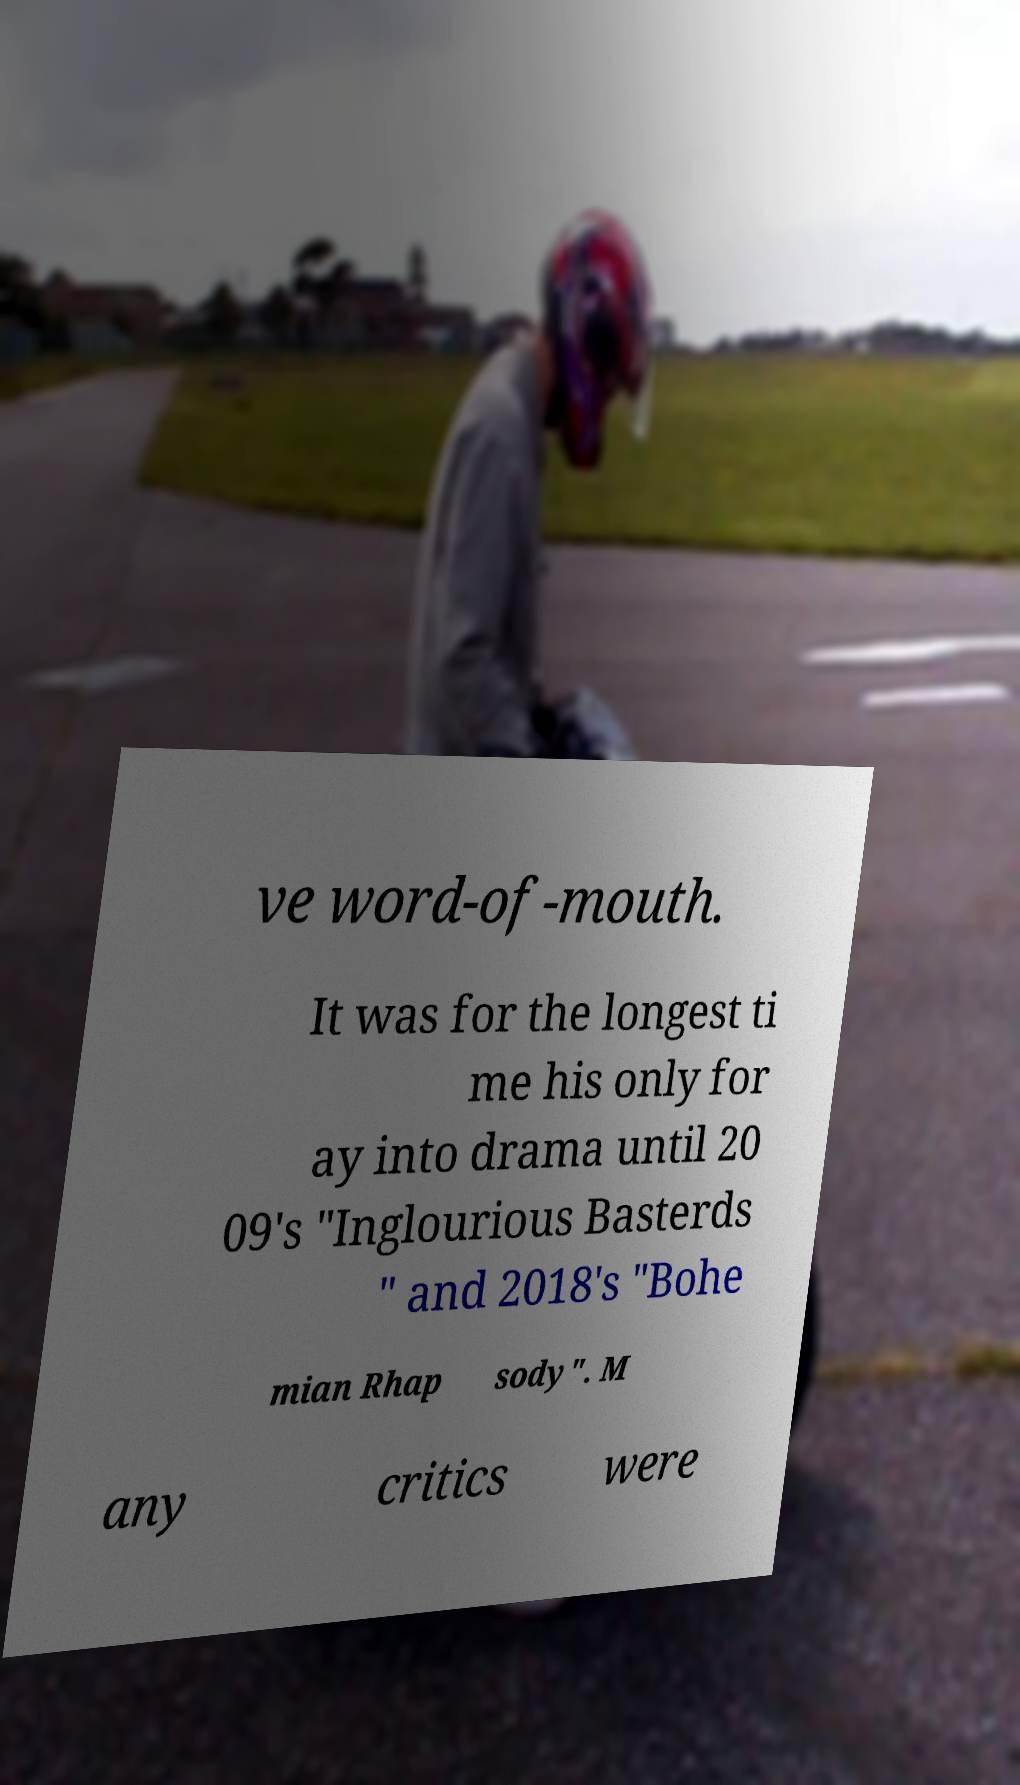Please identify and transcribe the text found in this image. ve word-of-mouth. It was for the longest ti me his only for ay into drama until 20 09's "Inglourious Basterds " and 2018's "Bohe mian Rhap sody". M any critics were 